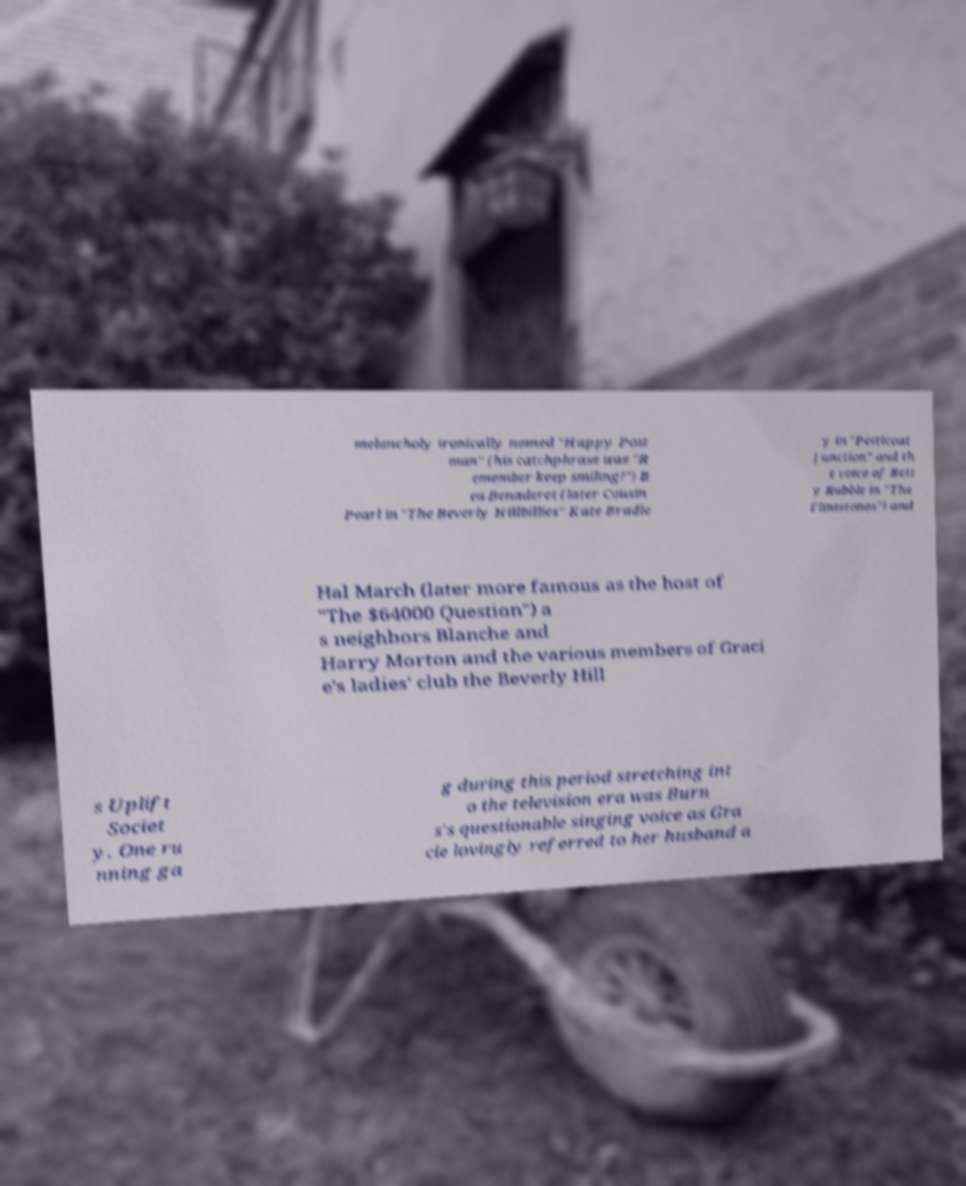I need the written content from this picture converted into text. Can you do that? melancholy ironically named "Happy Post man" (his catchphrase was "R emember keep smiling!") B ea Benaderet (later Cousin Pearl in "The Beverly Hillbillies" Kate Bradle y in "Petticoat Junction" and th e voice of Bett y Rubble in "The Flintstones") and Hal March (later more famous as the host of "The $64000 Question") a s neighbors Blanche and Harry Morton and the various members of Graci e's ladies' club the Beverly Hill s Uplift Societ y. One ru nning ga g during this period stretching int o the television era was Burn s's questionable singing voice as Gra cie lovingly referred to her husband a 